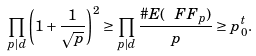<formula> <loc_0><loc_0><loc_500><loc_500>\prod _ { p | d } \left ( 1 + \frac { 1 } { \sqrt { p } } \right ) ^ { 2 } \geq \prod _ { p | d } \frac { \# E ( \ F F _ { p } ) } { p } \geq p _ { 0 } ^ { t } .</formula> 